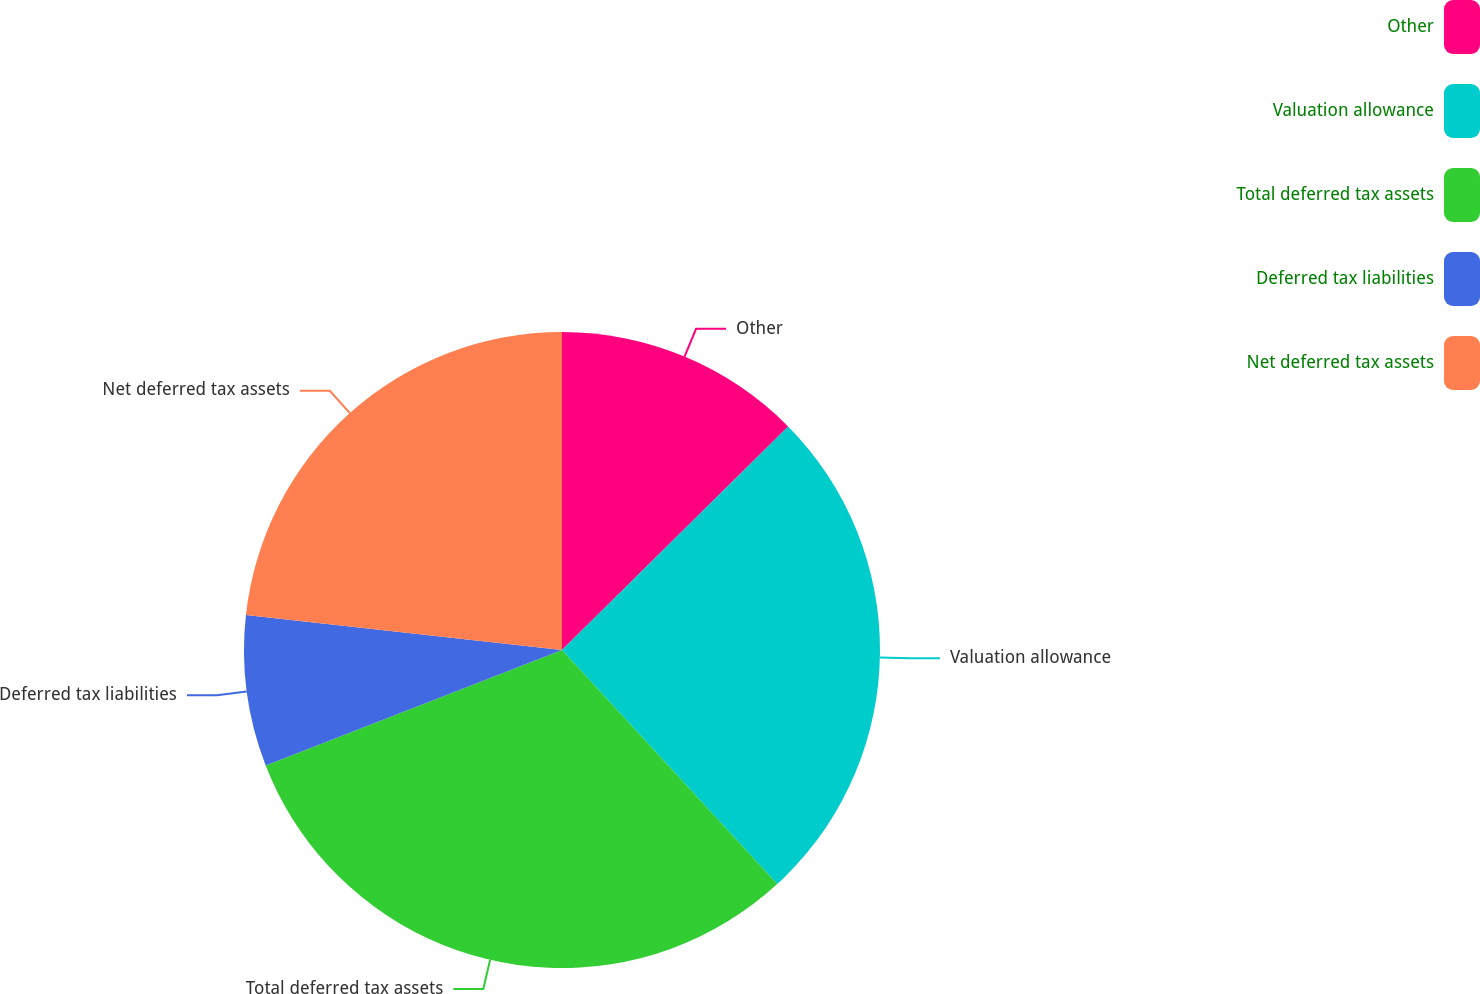<chart> <loc_0><loc_0><loc_500><loc_500><pie_chart><fcel>Other<fcel>Valuation allowance<fcel>Total deferred tax assets<fcel>Deferred tax liabilities<fcel>Net deferred tax assets<nl><fcel>12.59%<fcel>25.58%<fcel>30.92%<fcel>7.66%<fcel>23.25%<nl></chart> 